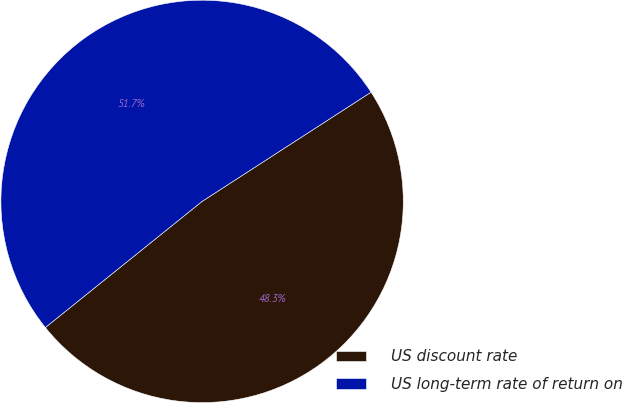Convert chart. <chart><loc_0><loc_0><loc_500><loc_500><pie_chart><fcel>US discount rate<fcel>US long-term rate of return on<nl><fcel>48.35%<fcel>51.65%<nl></chart> 